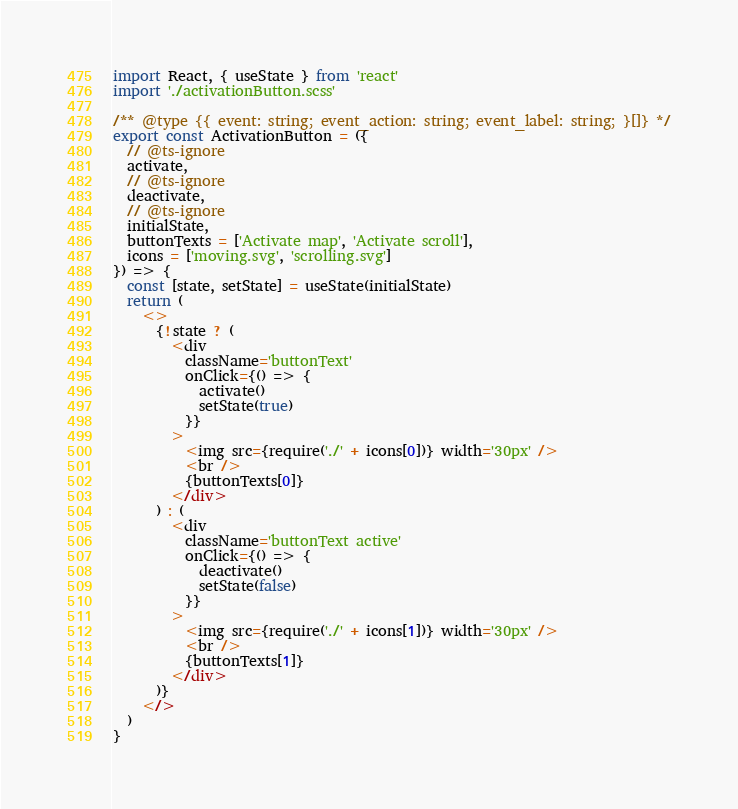Convert code to text. <code><loc_0><loc_0><loc_500><loc_500><_JavaScript_>import React, { useState } from 'react'
import './activationButton.scss'

/** @type {{ event: string; event_action: string; event_label: string; }[]} */
export const ActivationButton = ({
  // @ts-ignore
  activate,
  // @ts-ignore
  deactivate,
  // @ts-ignore
  initialState,
  buttonTexts = ['Activate map', 'Activate scroll'],
  icons = ['moving.svg', 'scrolling.svg']
}) => {
  const [state, setState] = useState(initialState)
  return (
    <>
      {!state ? (
        <div
          className='buttonText'
          onClick={() => {
            activate()
            setState(true)
          }}
        >
          <img src={require('./' + icons[0])} width='30px' />
          <br />
          {buttonTexts[0]}
        </div>
      ) : (
        <div
          className='buttonText active'
          onClick={() => {
            deactivate()
            setState(false)
          }}
        >
          <img src={require('./' + icons[1])} width='30px' />
          <br />
          {buttonTexts[1]}
        </div>
      )}
    </>
  )
}
</code> 